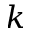Convert formula to latex. <formula><loc_0><loc_0><loc_500><loc_500>k</formula> 